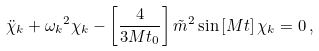Convert formula to latex. <formula><loc_0><loc_0><loc_500><loc_500>\ddot { \chi } _ { k } + { \omega _ { k } } ^ { 2 } \chi _ { k } - \left [ \frac { 4 } { 3 M t _ { 0 } } \right ] \tilde { m } ^ { 2 } \sin { [ M t ] } \, \chi _ { k } = 0 \, ,</formula> 